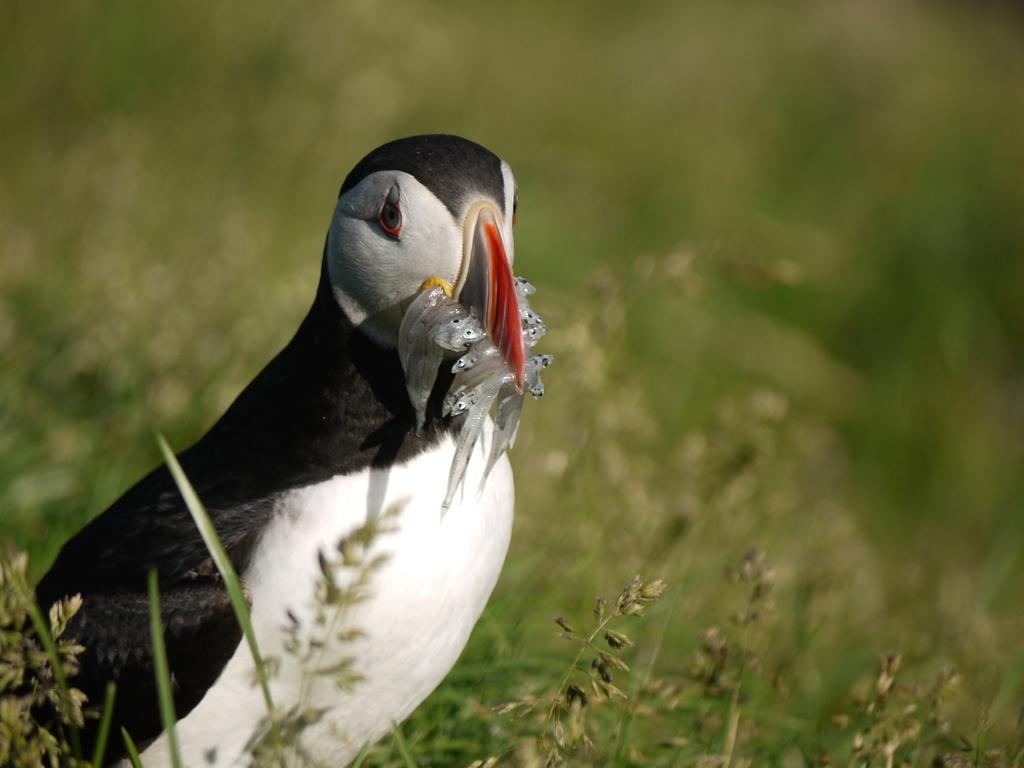What type of vegetation is visible in the image? There is grass in the image. What animal can be seen in the image? There is a bird in the image. What is the bird holding in its beak? The bird has fishes in its beak. How would you describe the background of the image? The background of the image is blurred. Is there any evidence of slavery in the image? No, there is no mention or indication of slavery in the image. Can you tell me the credit score of the bird in the image? There is no information about credit scores in the image, as it features a bird with fishes in its beak. 